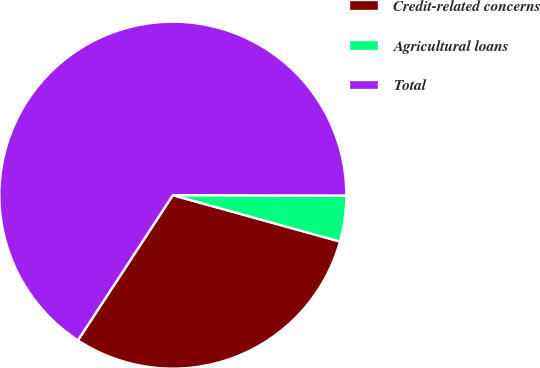<chart> <loc_0><loc_0><loc_500><loc_500><pie_chart><fcel>Credit-related concerns<fcel>Agricultural loans<fcel>Total<nl><fcel>29.91%<fcel>4.27%<fcel>65.81%<nl></chart> 